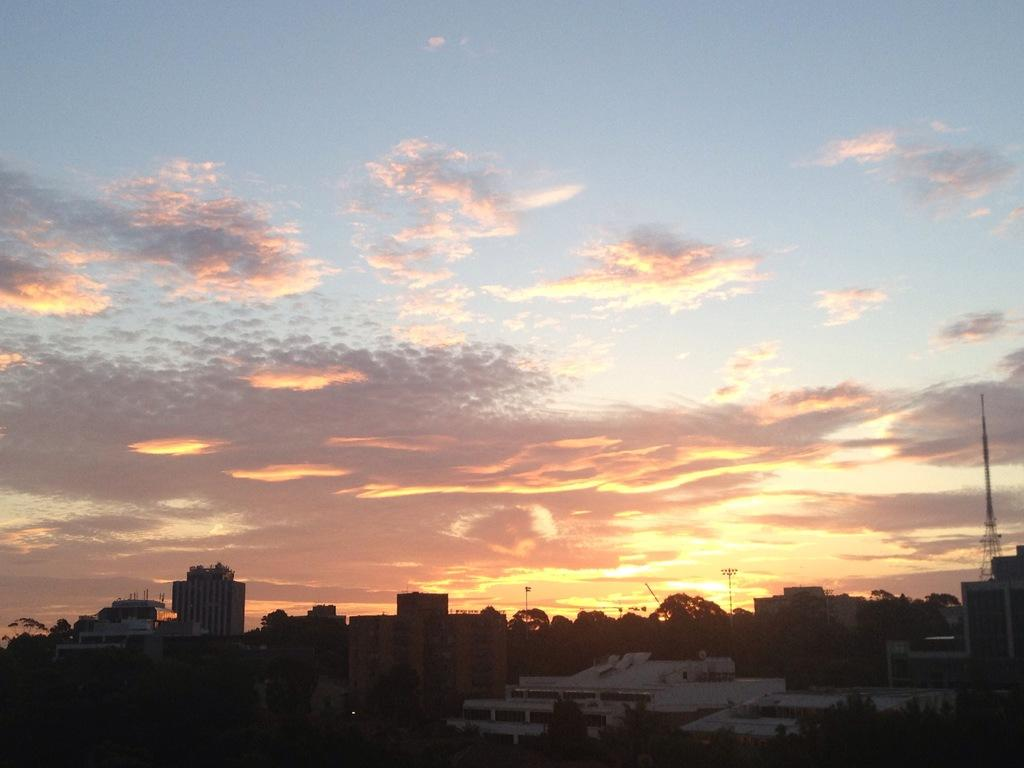What type of structures can be seen in the image? There are buildings and houses in the image. What other objects are present in the image? There are poles and lights visible in the image. What is the tallest structure in the image? There is a tower in the image. What is visible at the top of the image? The sky is visible at the top of the image. Reasoning: Let's think step by step by following the provided facts to create the conversation. We start by identifying the main subjects in the image, which are the buildings and houses. Then, we expand the conversation to include other objects that are also visible, such as poles, lights, and the tower. Each question is designed to elicit a specific detail about the image that is known from the provided facts. Absurd Question/Answer: What type of dress is the turkey wearing in the image? There is no turkey or dress present in the image. What type of beef is being cooked in the image? There is no beef present in the image. 